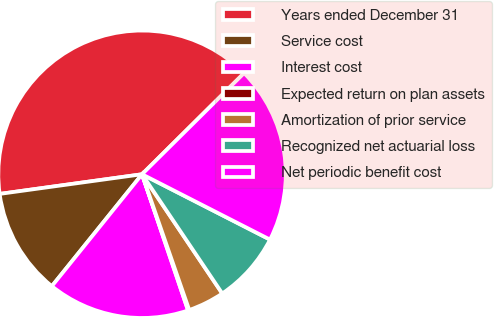<chart> <loc_0><loc_0><loc_500><loc_500><pie_chart><fcel>Years ended December 31<fcel>Service cost<fcel>Interest cost<fcel>Expected return on plan assets<fcel>Amortization of prior service<fcel>Recognized net actuarial loss<fcel>Net periodic benefit cost<nl><fcel>39.75%<fcel>12.02%<fcel>15.98%<fcel>0.14%<fcel>4.1%<fcel>8.06%<fcel>19.94%<nl></chart> 